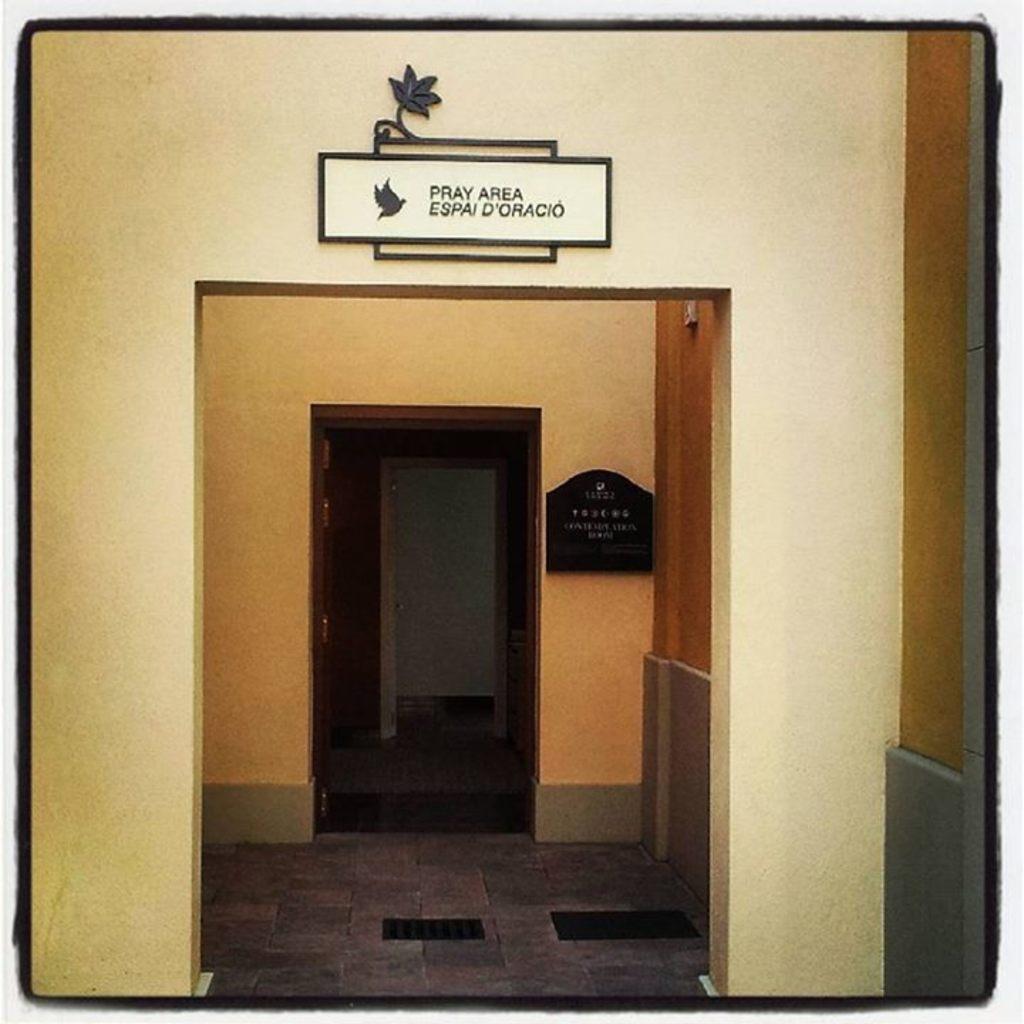In one or two sentences, can you explain what this image depicts? In this image in the front there is a wall and on the top of the wall there are frames hanging, on the frame there is some text written on it and in the center there is a black colour frame hanging on the wall with some text written on it. 